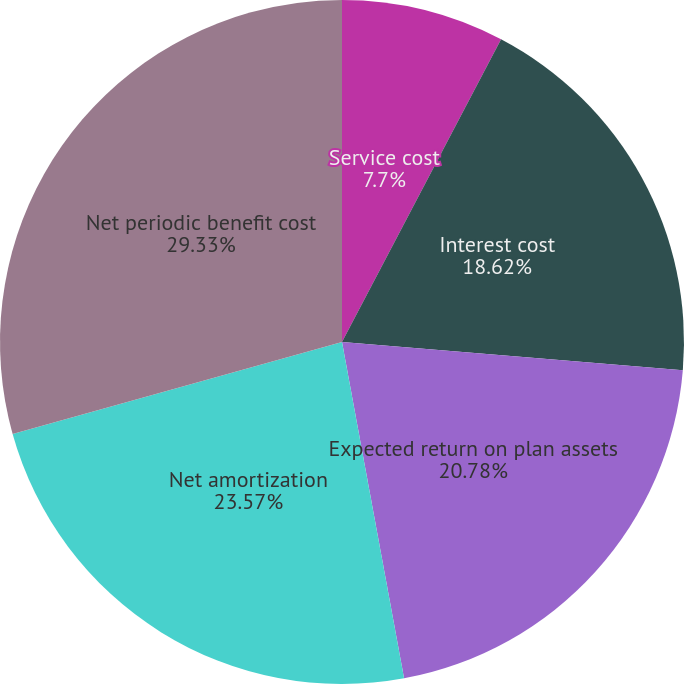<chart> <loc_0><loc_0><loc_500><loc_500><pie_chart><fcel>Service cost<fcel>Interest cost<fcel>Expected return on plan assets<fcel>Net amortization<fcel>Net periodic benefit cost<nl><fcel>7.7%<fcel>18.62%<fcel>20.78%<fcel>23.57%<fcel>29.34%<nl></chart> 